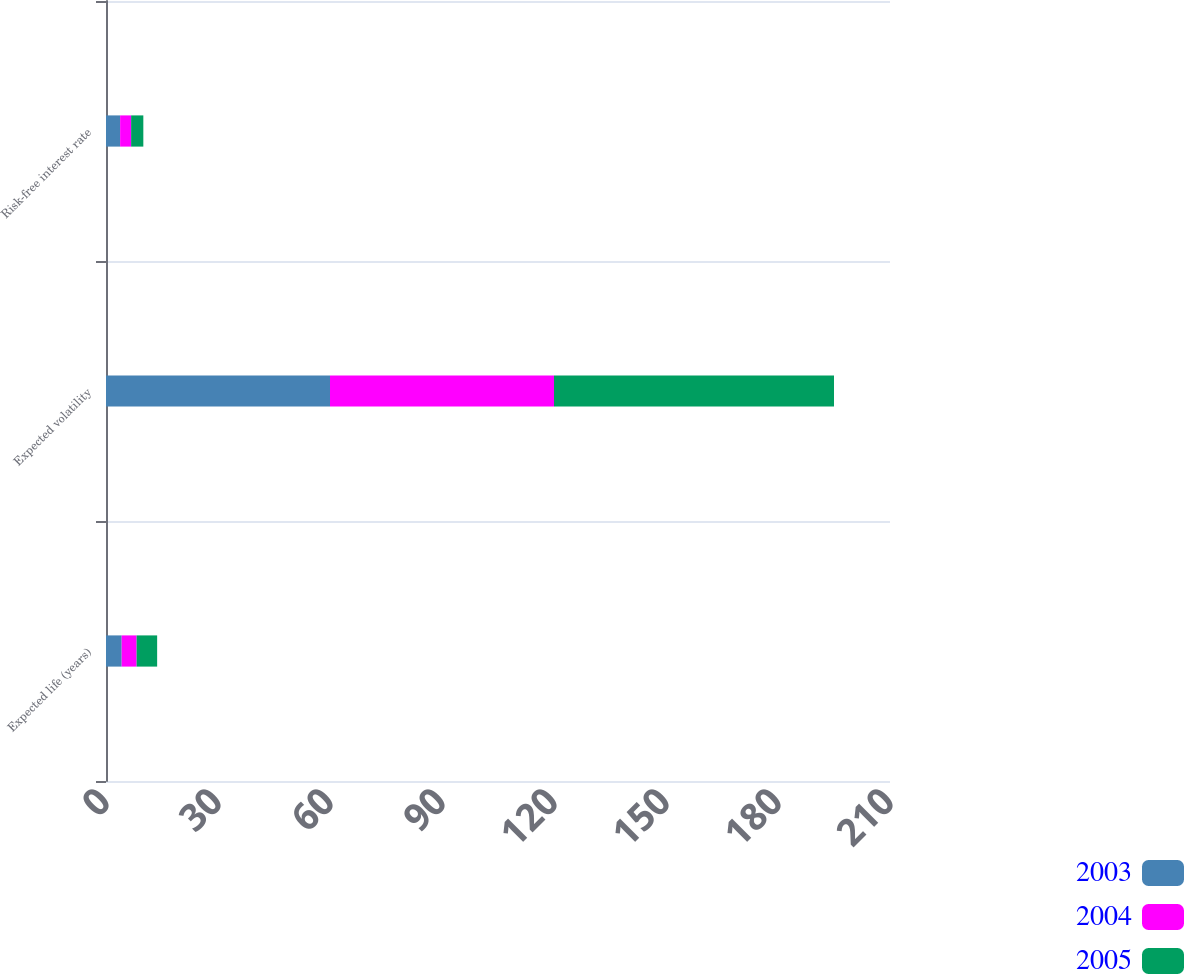Convert chart to OTSL. <chart><loc_0><loc_0><loc_500><loc_500><stacked_bar_chart><ecel><fcel>Expected life (years)<fcel>Expected volatility<fcel>Risk-free interest rate<nl><fcel>2003<fcel>4.2<fcel>60<fcel>3.78<nl><fcel>2004<fcel>4<fcel>60<fcel>2.95<nl><fcel>2005<fcel>5.5<fcel>75<fcel>3.27<nl></chart> 